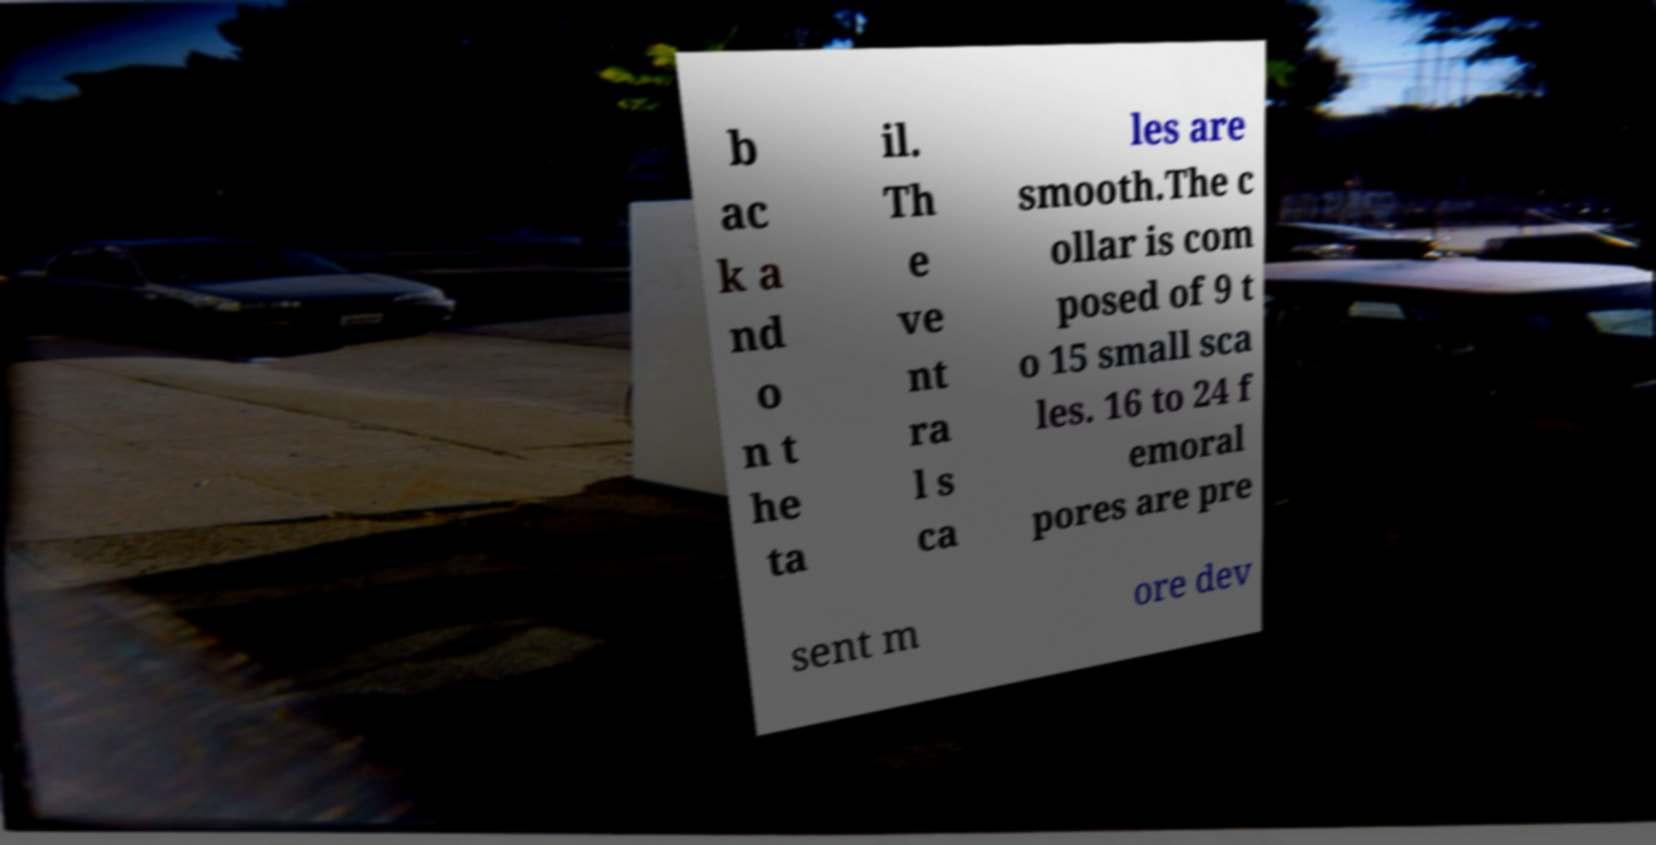Please read and relay the text visible in this image. What does it say? b ac k a nd o n t he ta il. Th e ve nt ra l s ca les are smooth.The c ollar is com posed of 9 t o 15 small sca les. 16 to 24 f emoral pores are pre sent m ore dev 